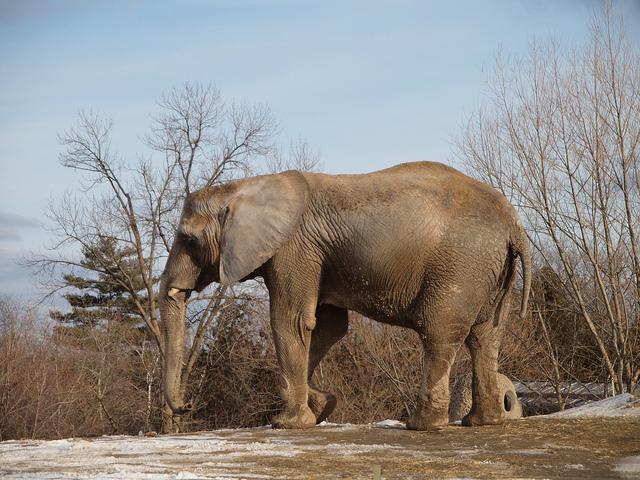Is this a full grown elephant?
Concise answer only. Yes. Which animals are they?
Keep it brief. Elephant. Is the sky blue?
Quick response, please. Yes. What is white on the ground?
Quick response, please. Snow. 